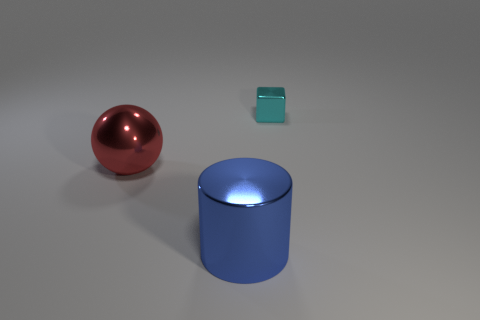Are there fewer big things that are in front of the big blue metal object than yellow metallic cylinders?
Your response must be concise. No. How many red metallic objects are right of the blue metallic object?
Your response must be concise. 0. The shiny object that is behind the cylinder and to the left of the tiny thing has what shape?
Give a very brief answer. Sphere. There is a cube that is made of the same material as the cylinder; what is its size?
Offer a very short reply. Small. Are there fewer large metal cylinders than big blue metallic cubes?
Keep it short and to the point. No. Is the large thing that is behind the large metal cylinder made of the same material as the object right of the blue object?
Provide a short and direct response. Yes. There is a shiny object that is to the right of the red thing and behind the blue thing; what is its size?
Give a very brief answer. Small. There is a shiny object on the left side of the large thing that is in front of the big red ball; how many big things are on the right side of it?
Keep it short and to the point. 1. What color is the object that is on the right side of the large ball and in front of the block?
Keep it short and to the point. Blue. What number of objects are the same size as the blue cylinder?
Offer a very short reply. 1. 